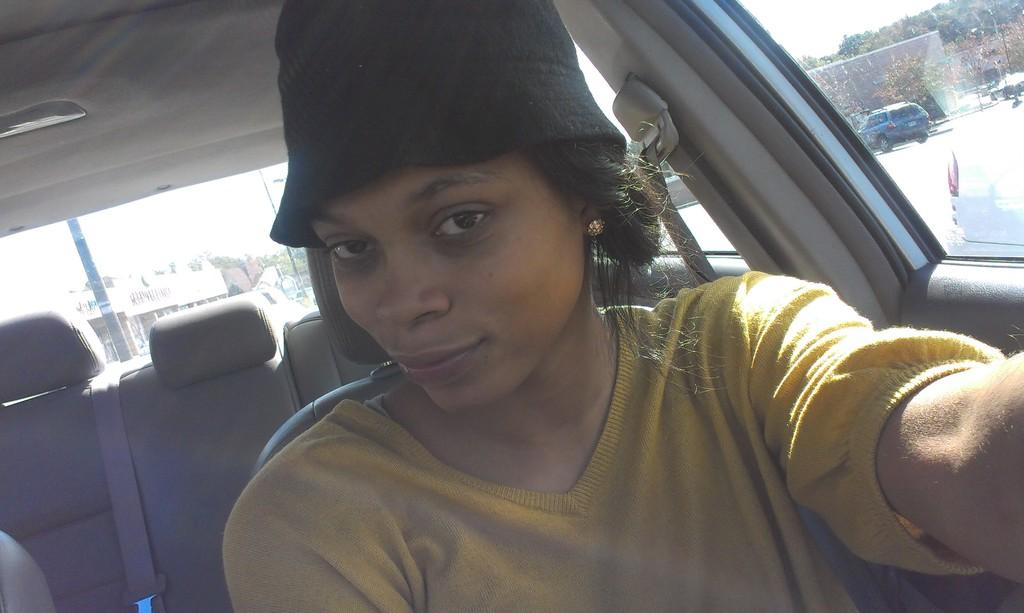Who is present in the image? There is a woman in the image. What is the woman wearing on her head? The woman is wearing a cap. Where is the woman located in the image? The woman is sitting inside a car. What is the woman's facial expression in the image? The woman is smiling. What can be seen through the car window in the image? Other cars on the road, trees, buildings, the sky, and a pole can be seen through the car window. What channel is the woman watching on the TV inside the car? There is no TV present in the image, so it is not possible to determine what channel the woman might be watching. 